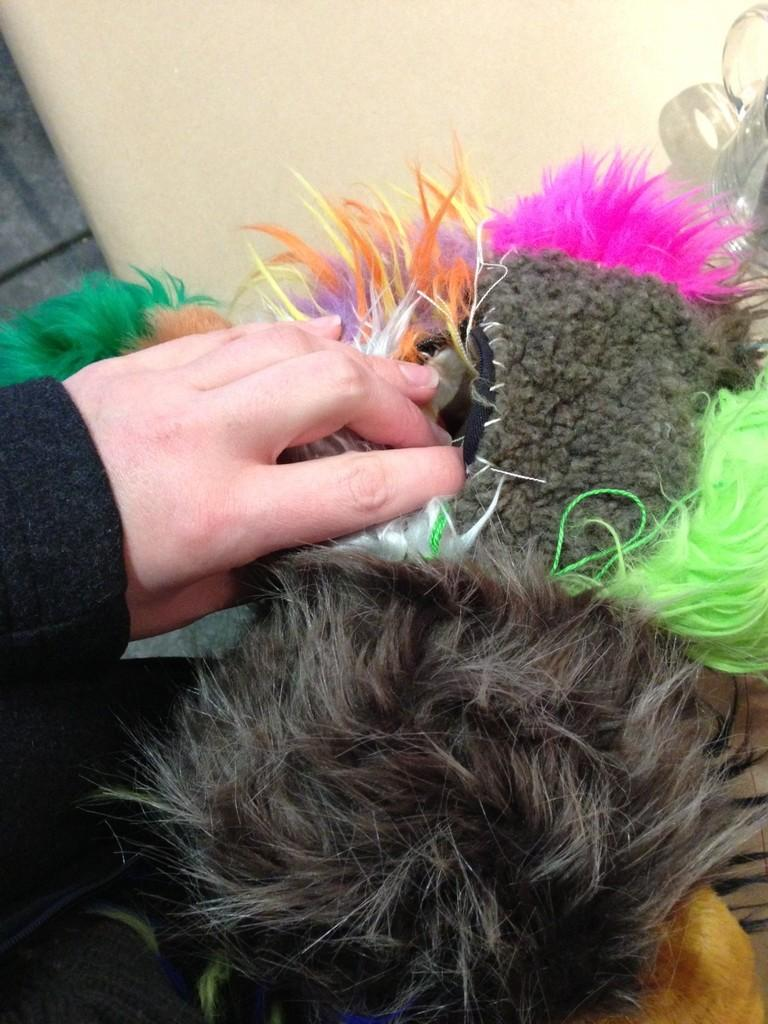What is the main subject in the center of the image? There is a toy in the center of the image. Who or what is holding the toy? The toy is being held by human hands. What can be seen in the background of the image? There is a wall in the background of the image. How many grapes are hanging from the toy in the image? There are no grapes present in the image; the toy is the main subject. 